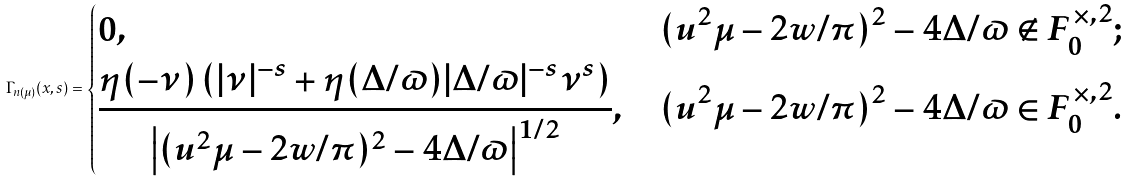<formula> <loc_0><loc_0><loc_500><loc_500>\Gamma _ { n ( \mu ) } ( x , s ) = \begin{dcases} 0 , & ( u ^ { 2 } \mu - 2 w / \pi ) ^ { 2 } - 4 \Delta / \varpi \notin F _ { 0 } ^ { \times , 2 } ; \\ \frac { \eta ( - \nu ) \left ( | \nu | ^ { - s } + \eta ( \Delta / \varpi ) | \Delta / \varpi | ^ { - s } \nu ^ { s } \right ) } { \left | ( u ^ { 2 } \mu - 2 w / \pi ) ^ { 2 } - 4 \Delta / \varpi \right | ^ { 1 / 2 } } , & ( u ^ { 2 } \mu - 2 w / \pi ) ^ { 2 } - 4 \Delta / \varpi \in F _ { 0 } ^ { \times , 2 } . \end{dcases}</formula> 